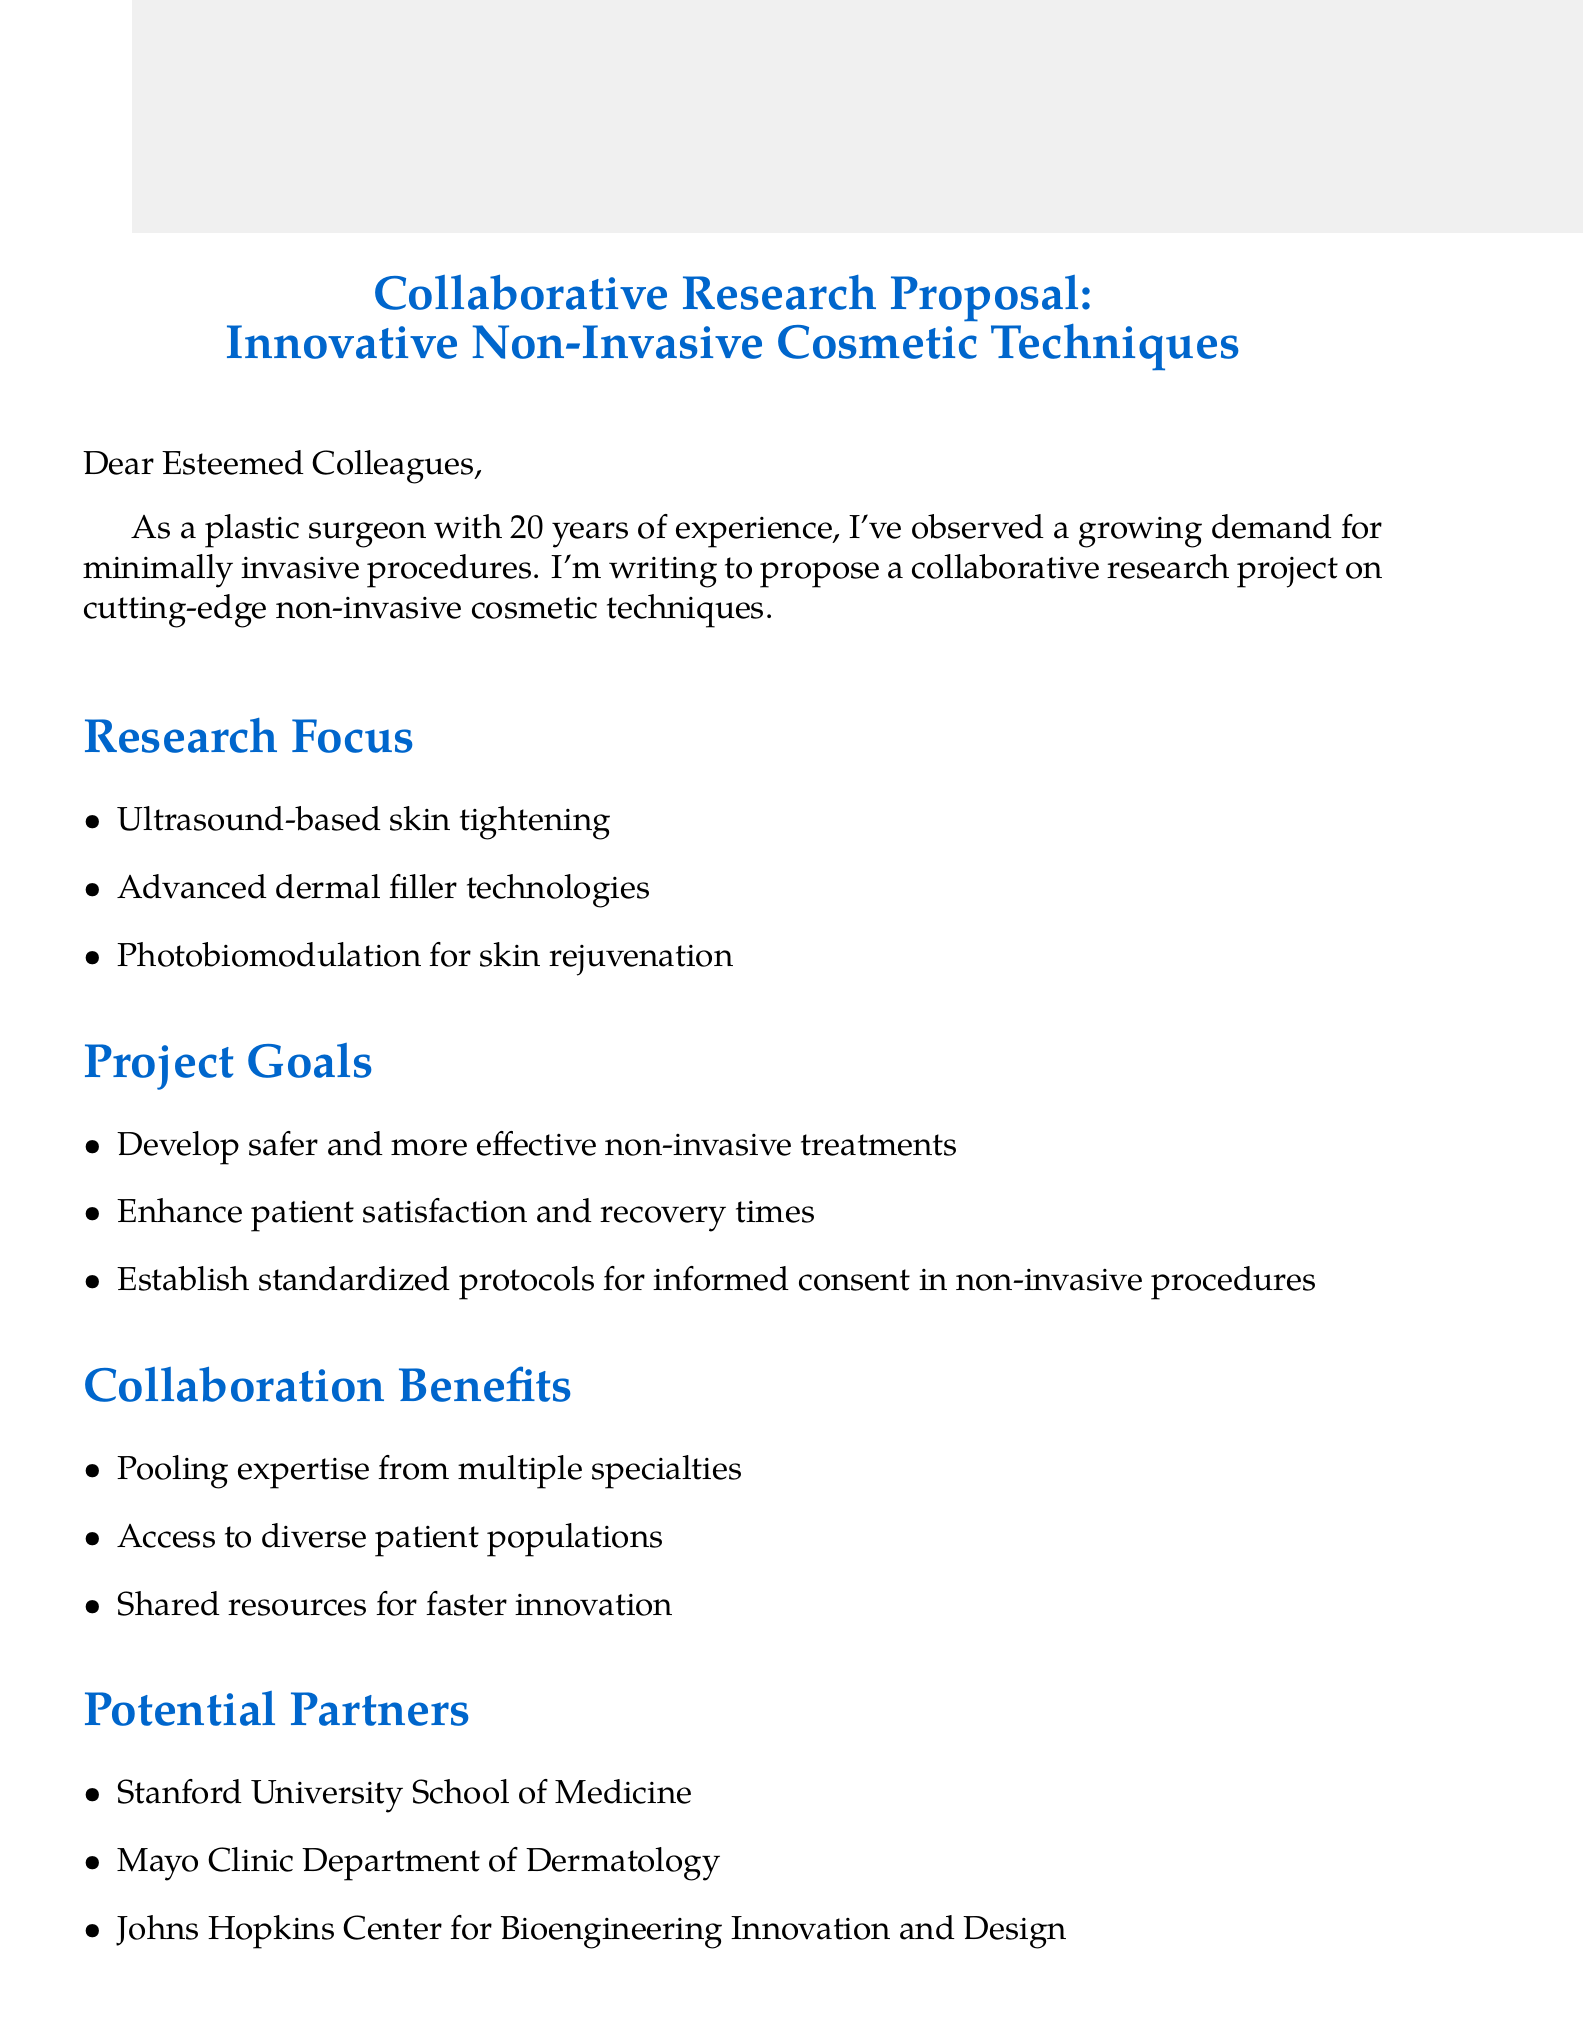What is the main purpose of the email? The main purpose stated in the email is to propose a collaborative research project on cutting-edge non-invasive cosmetic techniques.
Answer: Propose a collaborative research project How many years of experience does the author have? The author mentions having 20 years of experience as a plastic surgeon in the email.
Answer: 20 years Which project goal focuses on patient satisfaction? Enhancing patient satisfaction and recovery times is one of the project goals mentioned in the email.
Answer: Enhance patient satisfaction and recovery times What is one of the potential partners listed? The email lists Stanford University School of Medicine as one of the potential partners.
Answer: Stanford University School of Medicine By what date should interested parties respond? The email specifies that responses regarding interest and suggestions should be received by August 15, 2023.
Answer: August 15, 2023 What are the funding opportunities mentioned? The funding opportunities presented include the NIH R01 Research Project Grant and the ASPS Pilot Research Grant.
Answer: NIH R01 Research Project Grant, ASPS Pilot Research Grant What is the duration of the proposed project? The email indicates that the duration of the proposed project is 3 years.
Answer: 3 years What innovative technique is included in the research focus? One of the innovative techniques outlined in the research focus is ultrasound-based skin tightening.
Answer: Ultrasound-based skin tightening What is the closing statement of the email? The closing statement expresses the author's eagerness to advance the field of non-invasive cosmetic techniques together.
Answer: Looking forward to advancing the field of non-invasive cosmetic techniques together 